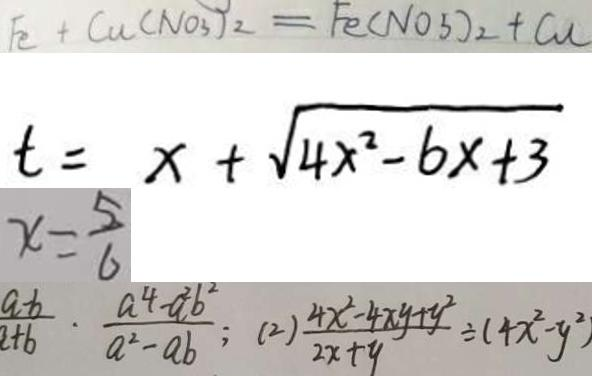<formula> <loc_0><loc_0><loc_500><loc_500>F e + C u ( N O _ { 3 } ) _ { 2 } = F e ( N O _ { 3 } ) _ { 2 } + C u 
 t = x + \sqrt { 4 x ^ { 2 } - 6 x + 3 } 
 x = \frac { 5 } { 6 } 
 \frac { a - b } { a + b } \cdot \frac { a ^ { 4 } - a ^ { 2 } b ^ { 2 } } { a ^ { 2 } - a b } ; ( 2 ) \frac { 4 x ^ { 2 } - 4 x y + y ^ { 2 } } { 2 x + y } \div ( 4 x ^ { 2 } - y ^ { 2 } )</formula> 